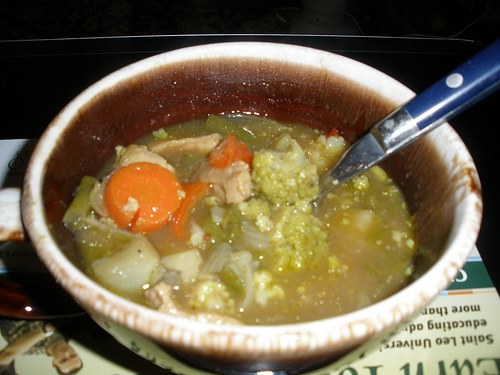Are there any onions to the right of the veggies that are in the soup? No, there are no onions to the right of the veggies in the soup. 